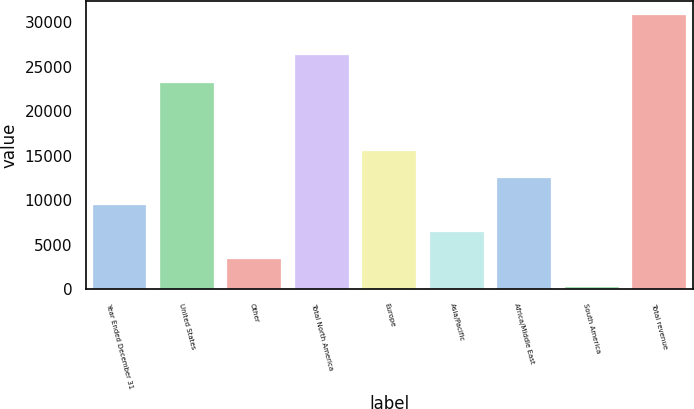Convert chart to OTSL. <chart><loc_0><loc_0><loc_500><loc_500><bar_chart><fcel>Year Ended December 31<fcel>United States<fcel>Other<fcel>Total North America<fcel>Europe<fcel>Asia/Pacific<fcel>Africa/Middle East<fcel>South America<fcel>Total revenue<nl><fcel>9448.1<fcel>23222<fcel>3332.7<fcel>26279.7<fcel>15563.5<fcel>6390.4<fcel>12505.8<fcel>275<fcel>30852<nl></chart> 